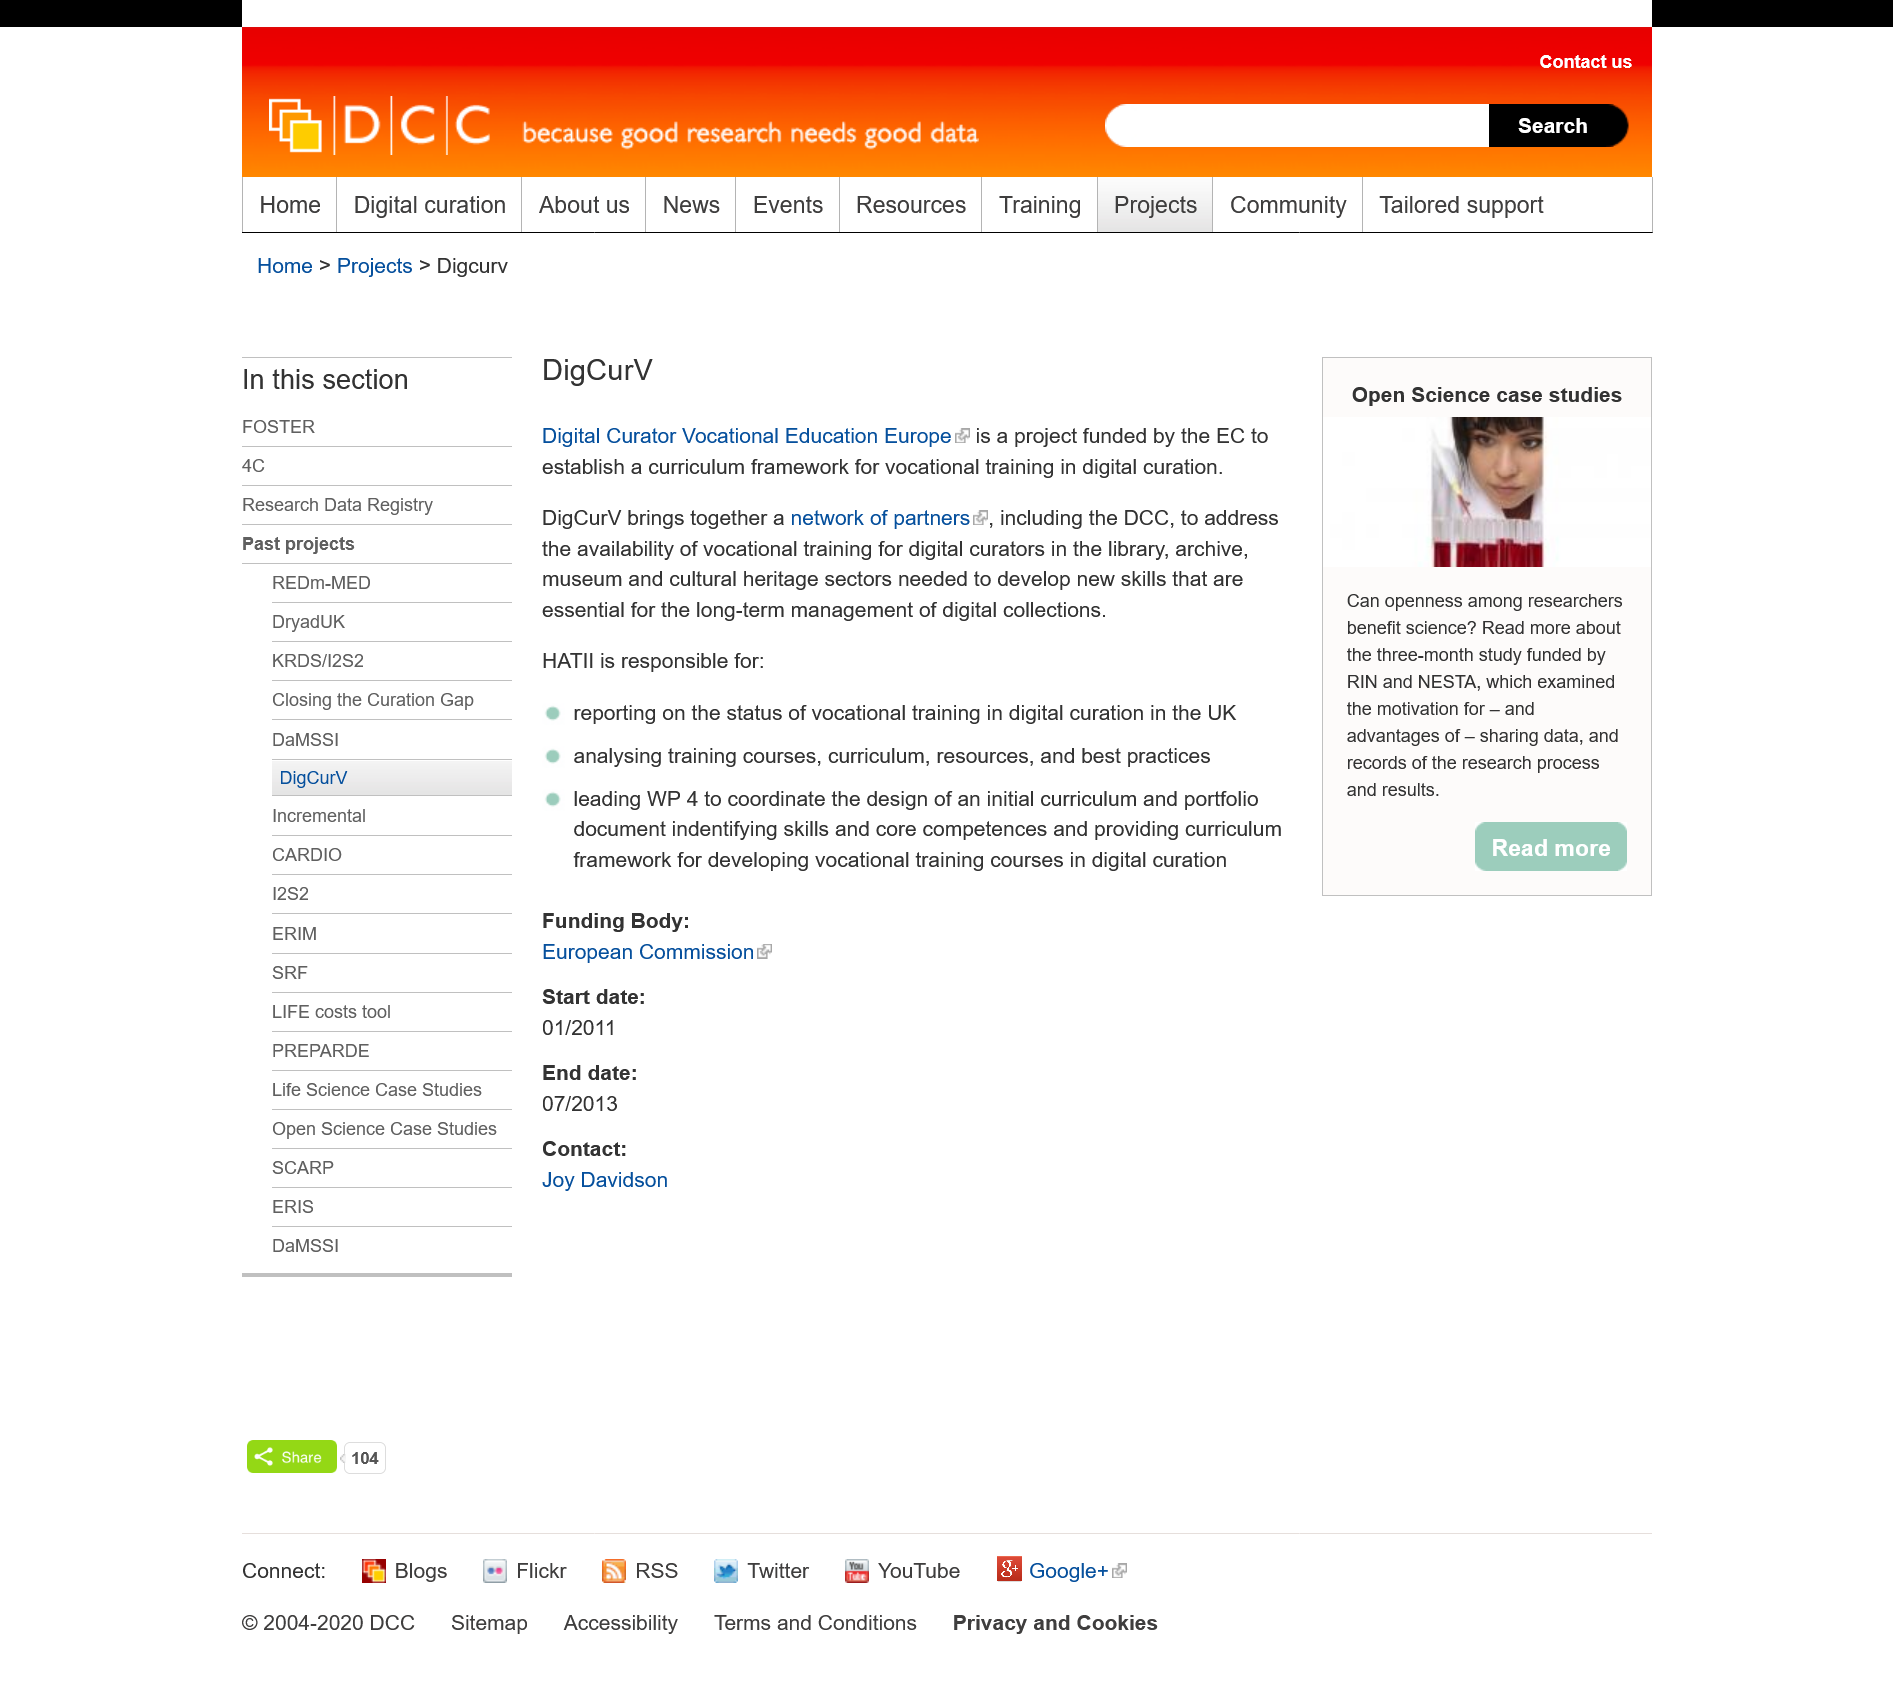Highlight a few significant elements in this photo. DigCurV, a network of partners united by a common goal, is a powerful force in the digital curation and variation space. The acronym "DigCurV" stands for "Digital Curator Vocational Education Europe. Who funds DigCurV? The European Commission does. 